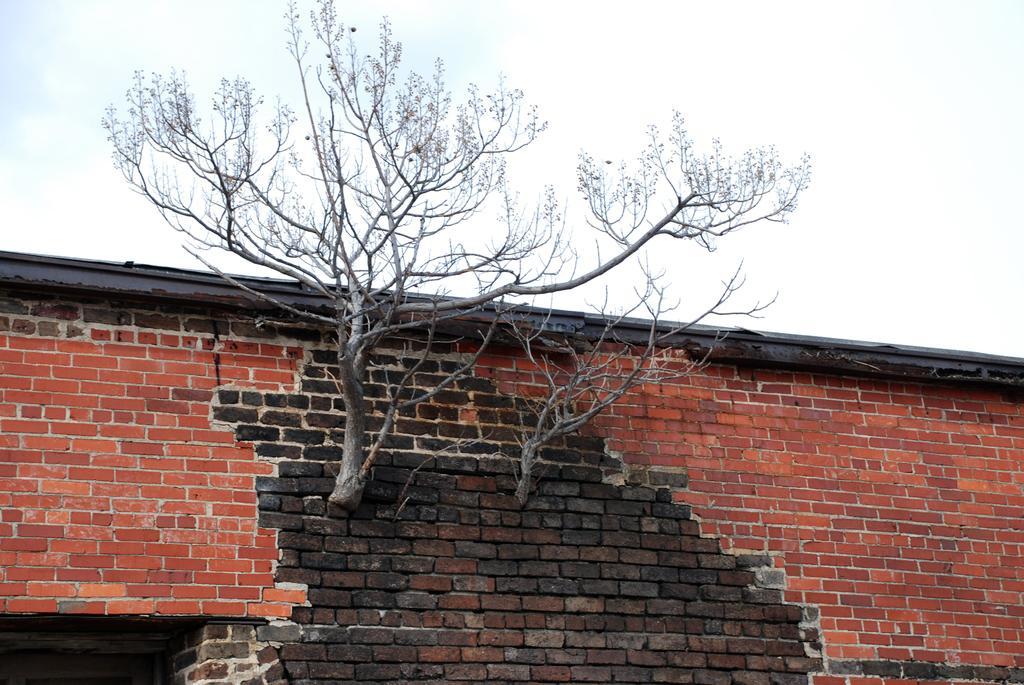In one or two sentences, can you explain what this image depicts? In this image, I can see the trees and a wall. In the background, there is the sky. 